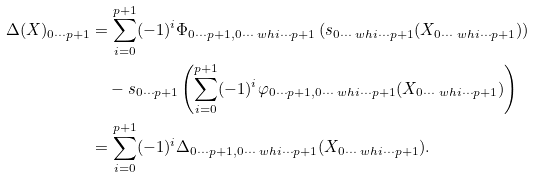<formula> <loc_0><loc_0><loc_500><loc_500>\Delta ( X ) _ { 0 \cdots p + 1 } & = \sum _ { i = 0 } ^ { p + 1 } ( - 1 ) ^ { i } \Phi _ { 0 \cdots p + 1 , 0 \cdots \ w h { i } \cdots p + 1 } \left ( s _ { 0 \cdots \ w h { i } \cdots p + 1 } ( X _ { 0 \cdots \ w h { i } \cdots p + 1 } ) \right ) \\ & \quad - s _ { 0 \cdots p + 1 } \left ( \sum _ { i = 0 } ^ { p + 1 } ( - 1 ) ^ { i } \varphi _ { 0 \cdots p + 1 , 0 \cdots \ w h { i } \cdots p + 1 } ( X _ { 0 \cdots \ w h { i } \cdots p + 1 } ) \right ) \\ & = \sum _ { i = 0 } ^ { p + 1 } ( - 1 ) ^ { i } \Delta _ { 0 \cdots p + 1 , 0 \cdots \ w h { i } \cdots p + 1 } ( X _ { 0 \cdots \ w h { i } \cdots p + 1 } ) .</formula> 